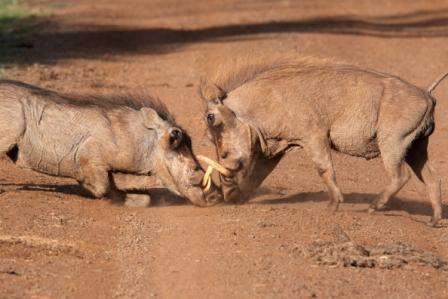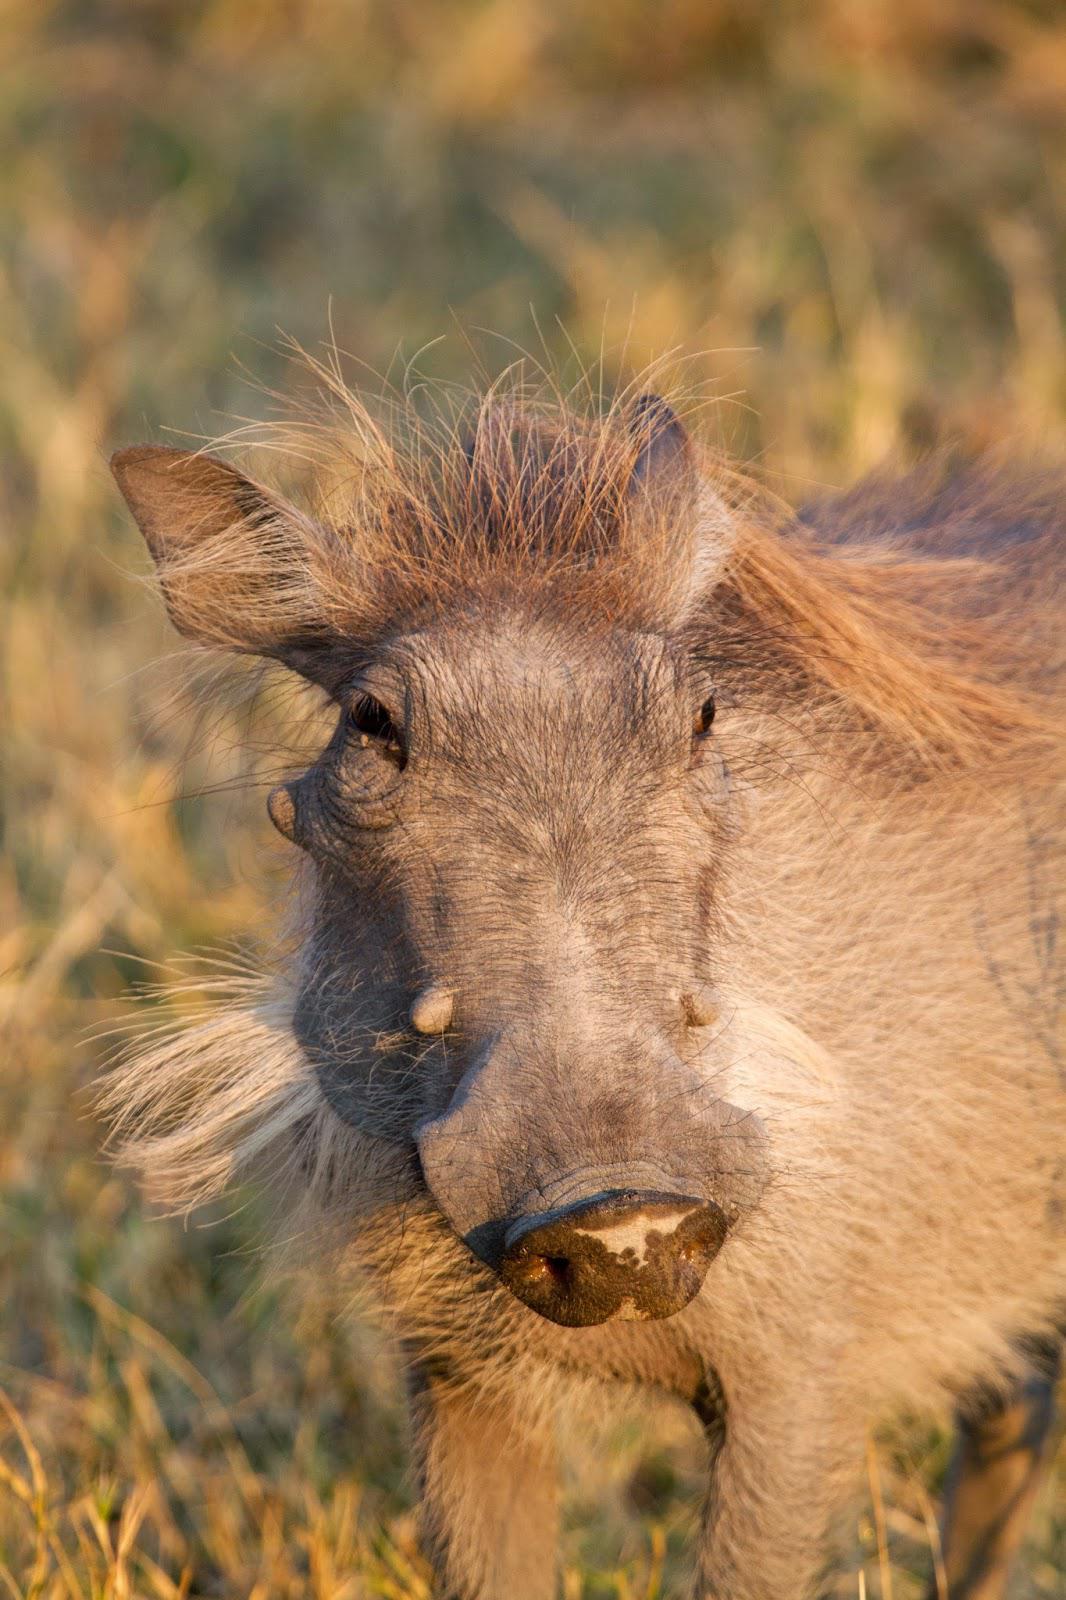The first image is the image on the left, the second image is the image on the right. Assess this claim about the two images: "There is exactly two warthogs in the left image.". Correct or not? Answer yes or no. Yes. The first image is the image on the left, the second image is the image on the right. For the images shown, is this caption "The right image contains twice as many warthogs as the left image, and all warthogs are turned forward instead of in profile or backward." true? Answer yes or no. No. 